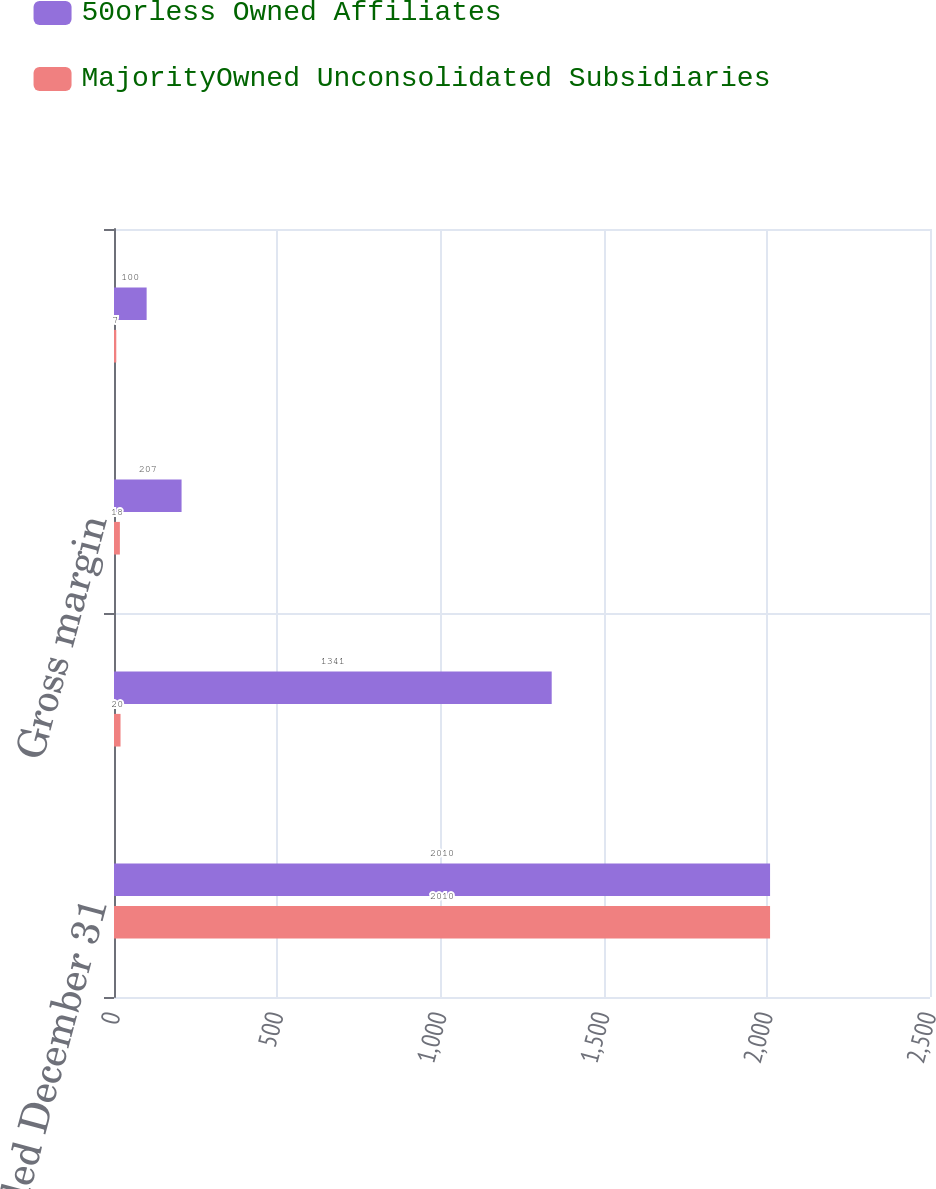<chart> <loc_0><loc_0><loc_500><loc_500><stacked_bar_chart><ecel><fcel>Years ended December 31<fcel>Revenue<fcel>Gross margin<fcel>Net income (loss)<nl><fcel>50orless Owned Affiliates<fcel>2010<fcel>1341<fcel>207<fcel>100<nl><fcel>MajorityOwned Unconsolidated Subsidiaries<fcel>2010<fcel>20<fcel>18<fcel>7<nl></chart> 